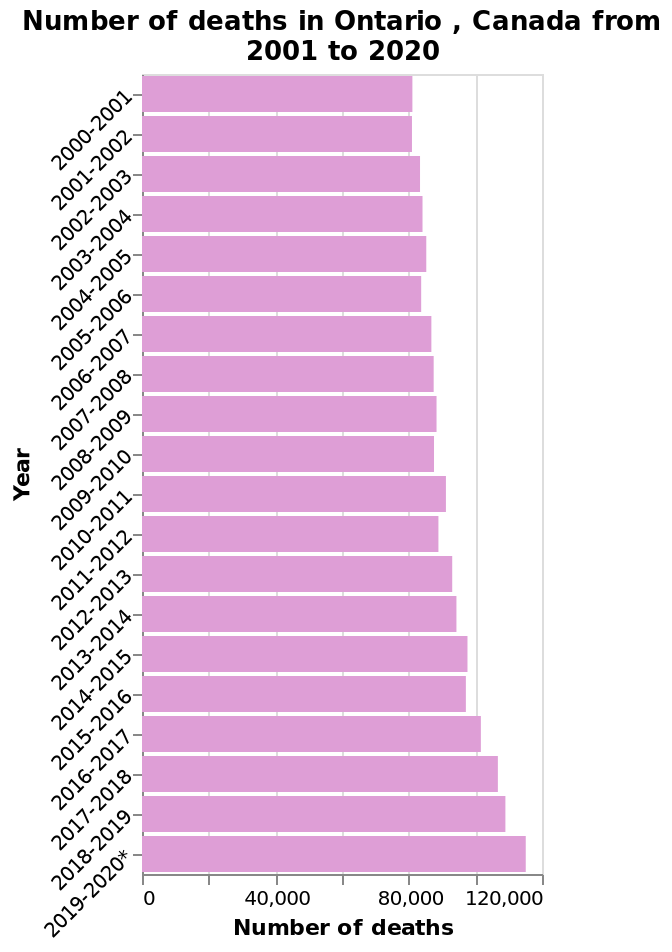<image>
Has the number of deaths in Ontario Canada been increasing or decreasing? The number of deaths in Ontario Canada has been increasing. please describe the details of the chart Number of deaths in Ontario , Canada from 2001 to 2020 is a bar plot. The y-axis measures Year while the x-axis measures Number of deaths. 